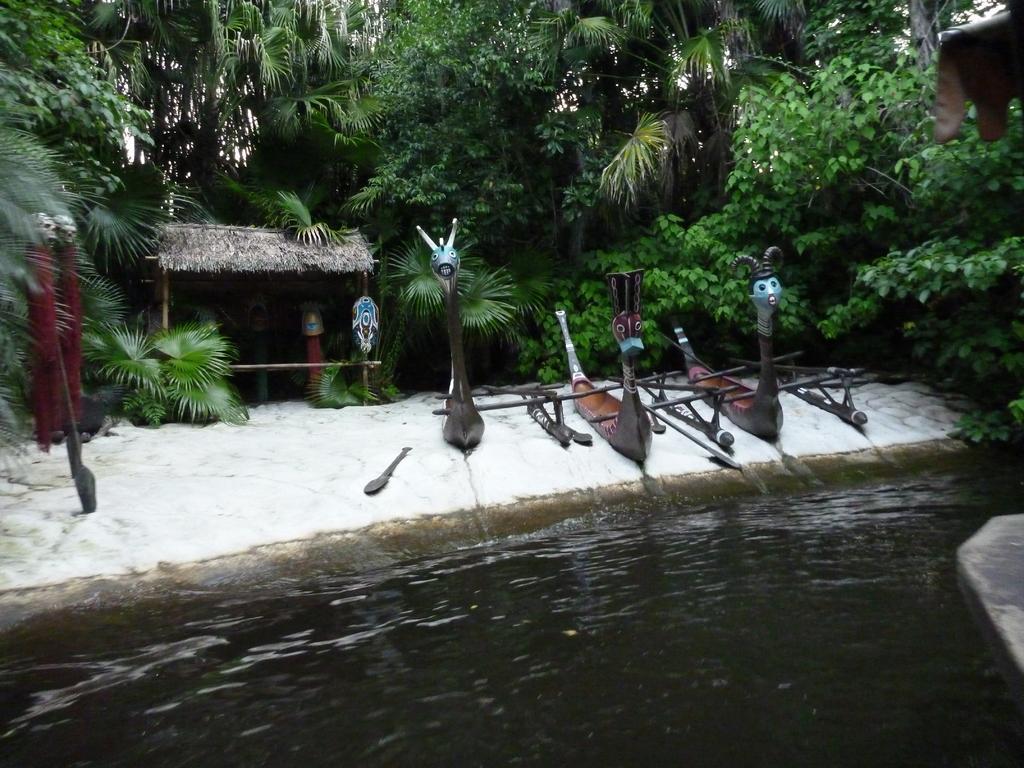Describe this image in one or two sentences. In this picture we can observe a lake. There are some boards. In this picture we can observe a small hut. In the background there are trees. 